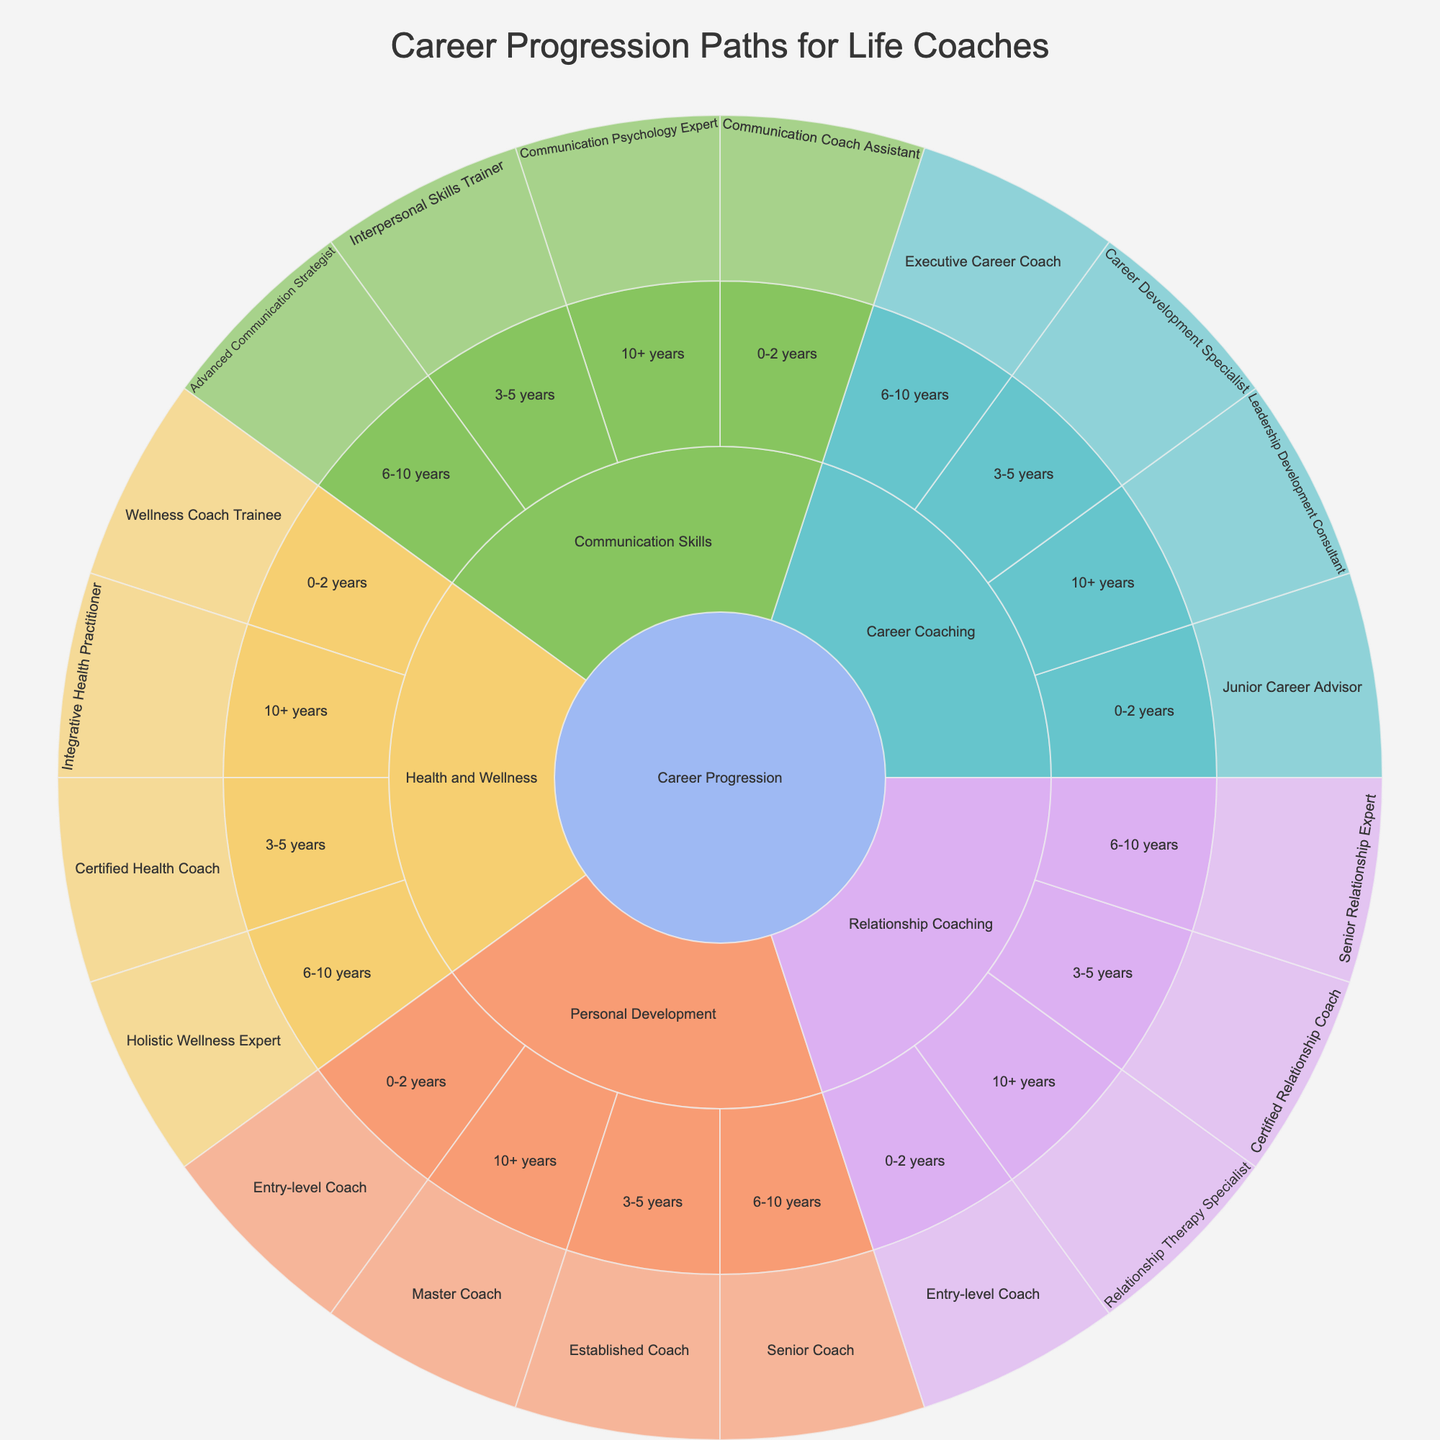What is the title of the Sunburst Plot? The title is located at the top of the plot and usually provides an overall description of the visualization.
Answer: Career Progression Paths for Life Coaches How many specializations are there in the career progression paths for life coaches? To find the number of specializations, look at the first layer of segments branching directly from the root "Career Progression." Each segment represents a specialization.
Answer: 5 What is the career path for a life coach with 3-5 years of experience in Relationship Coaching? Navigate the sunburst plot starting from "Career Progression," then to "Relationship Coaching," and finally locate the segment for "3-5 years." The corresponding path is the label of the innermost segment.
Answer: Certified Relationship Coach Compare the number of career paths available for those with 0-2 years of experience versus those with 10+ years of experience. Count the number of segments corresponding to career paths for life coaches with 0-2 years of experience and those with 10+ years. There are 5 segments for each experience level.
Answer: They are equal Which specialization leads to an "Integrative Health Practitioner" role, and what experience level is required? Identify the segment labeled "Integrative Health Practitioner" and trace back to find the parent segments. The immediate parent is related to specialization and the grandparent to experience.
Answer: Health and Wellness, 10+ years What role can a life coach with 6-10 years of experience in Career Coaching attain? From the root "Career Progression," navigate to "Career Coaching," then to the segment for "6-10 years." The innermost segment name is the role attained.
Answer: Executive Career Coach What is the next level career progression for a coach specializing in Communication Skills with 3-5 years of experience? Navigate from "Communication Skills" to "3-5 years," and identify the label of the innermost segment.
Answer: Interpersonal Skills Trainer Which specialization requires a "Master Coach" title, and at what experience level does this occur? Find the segment labeled "Master Coach" and trace back to identify the parent segment (specialization) and grandparent segment (experience level).
Answer: Personal Development, 10+ years Is there any specialization that doesn't lead to a "Senior" title at 6-10 years of experience? Examine each specialization segment linked to "6-10 years" and check if "Senior" appears in the path names repeatedly. There's one specialization which does not follow this pattern.
Answer: Career Coaching How many paths are related to "Health and Wellness"? Count all the segments branching from the "Health and Wellness" specialization segment. Each segment represents a path.
Answer: 4 